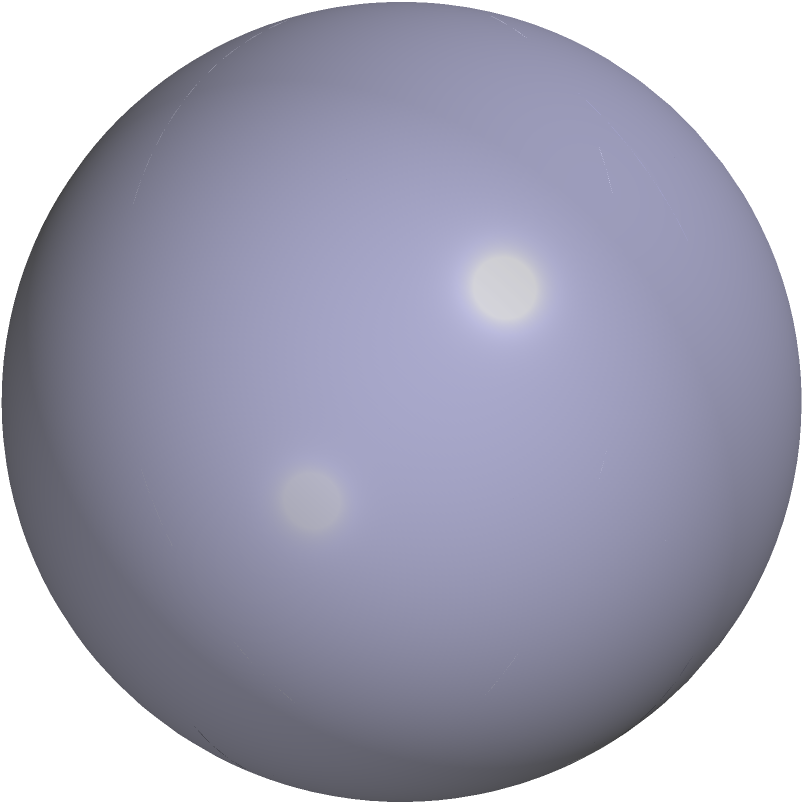In the context of preserving historical landmarks, understanding geometric principles can be crucial for architects and conservationists. Consider a circle with radius $r$ drawn on a flat plane and on the surface of a sphere with the same radius $r$. If the radius is equal to the radius of the sphere, how does the area of the circle on the sphere compare to the area of the circle on the flat plane? Express your answer as a ratio of the spherical circle's area to the flat circle's area. Let's approach this step-by-step:

1) For a circle on a flat plane:
   Area = $\pi r^2$

2) For a circle on a sphere (when the circle's radius equals the sphere's radius):
   The circle becomes a hemisphere.
   Area of a hemisphere = $2\pi r^2$

3) Ratio of areas:
   $\frac{\text{Area of circle on sphere}}{\text{Area of circle on flat plane}} = \frac{2\pi r^2}{\pi r^2}$

4) Simplify:
   $\frac{2\pi r^2}{\pi r^2} = 2$

Therefore, the area of the circle on the sphere is twice the area of the circle on the flat plane when the radius of the circle equals the radius of the sphere.

This principle is crucial in understanding how geometric properties change on curved surfaces, which is relevant when preserving or reconstructing curved structures in historical landmarks.
Answer: 2:1 